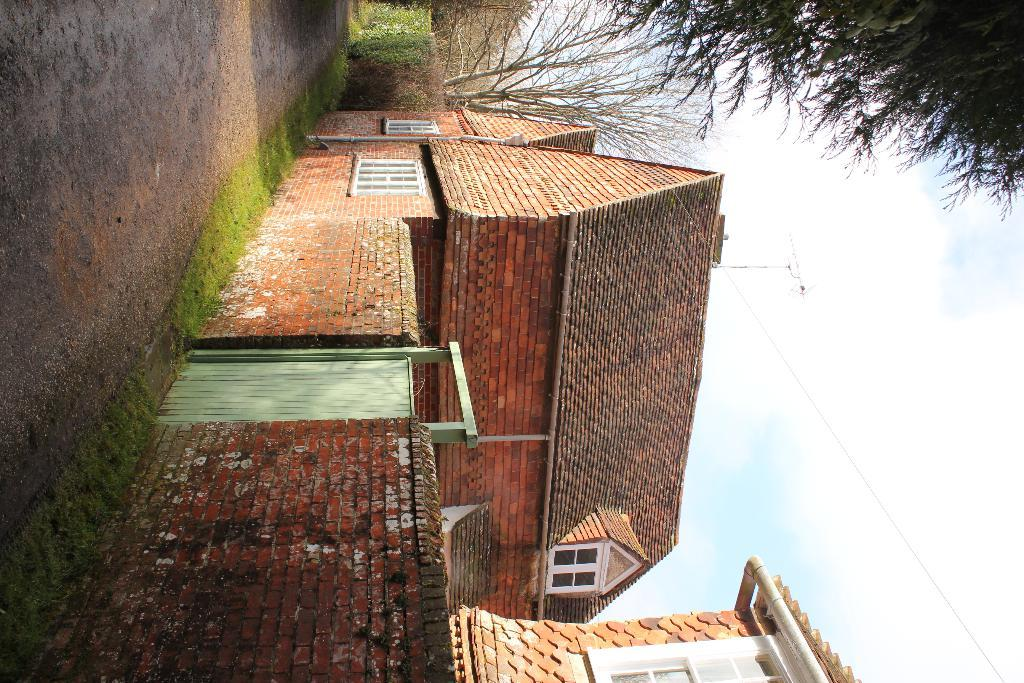What architectural feature is present in the image? There is a wall in the image. What can be seen in the houses? There are windows in the image. How can one enter or exit the houses? There is a door in the image. What is a long, narrow object in the image? There is a pipe in the image. What is used for receiving signals in the image? There is an antenna in the image. What type of vegetation is present in the image? There are plants in the image. What type of tall vegetation is present in the image? There are trees in the image. What is visible in the background of the image? The sky is visible in the background of the image. What type of nerve can be seen in the image? There is no nerve present in the image. How does the steam escape from the houses in the image? There is no steam present in the image. 